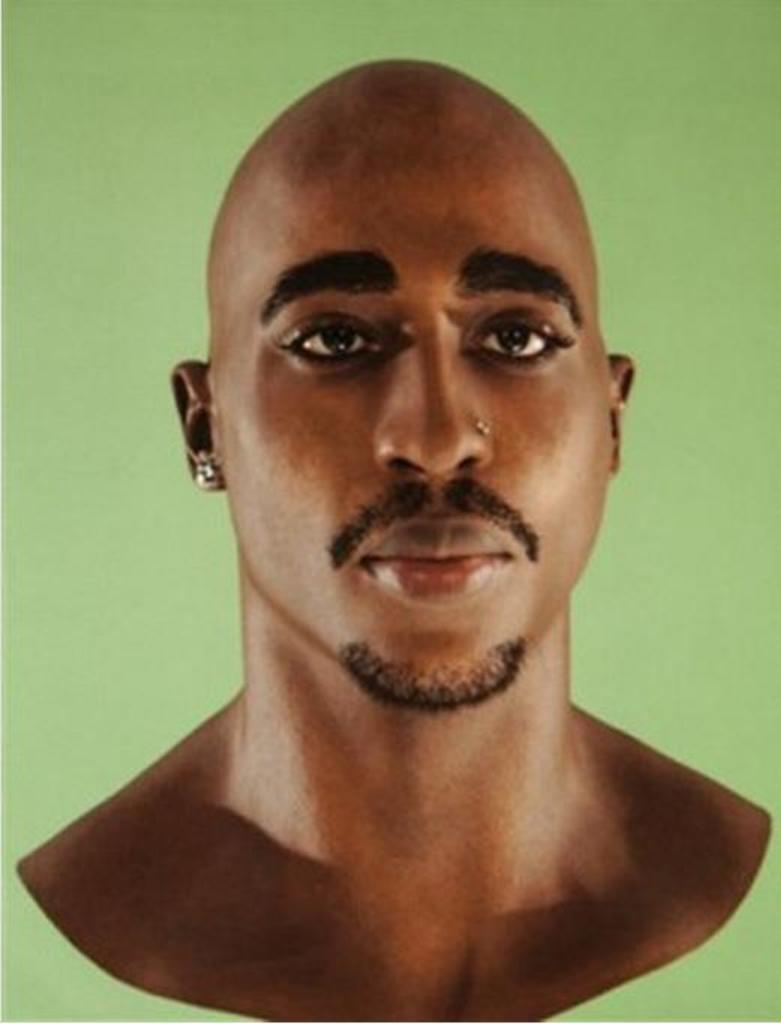What is the main subject of the image? The main subject of the image is a picture of a man. What type of accessory is the man wearing on his ear? The man is wearing a ring on his ear. What type of accessory is the man wearing on his nose? The man is wearing a ring on his nose. How many sisters does the man have in the image? There is no information about the man's sisters in the image. What is the man's occupation in the image? There is no information about the man's occupation in the image. 